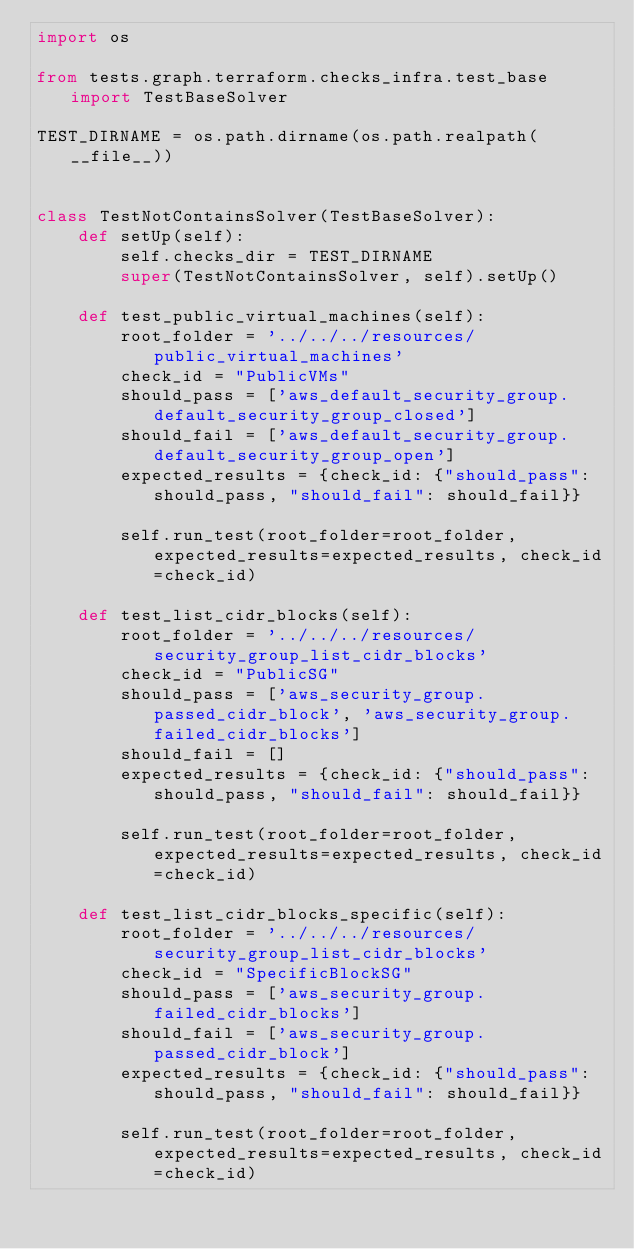<code> <loc_0><loc_0><loc_500><loc_500><_Python_>import os

from tests.graph.terraform.checks_infra.test_base import TestBaseSolver

TEST_DIRNAME = os.path.dirname(os.path.realpath(__file__))


class TestNotContainsSolver(TestBaseSolver):
    def setUp(self):
        self.checks_dir = TEST_DIRNAME
        super(TestNotContainsSolver, self).setUp()

    def test_public_virtual_machines(self):
        root_folder = '../../../resources/public_virtual_machines'
        check_id = "PublicVMs"
        should_pass = ['aws_default_security_group.default_security_group_closed']
        should_fail = ['aws_default_security_group.default_security_group_open']
        expected_results = {check_id: {"should_pass": should_pass, "should_fail": should_fail}}

        self.run_test(root_folder=root_folder, expected_results=expected_results, check_id=check_id)

    def test_list_cidr_blocks(self):
        root_folder = '../../../resources/security_group_list_cidr_blocks'
        check_id = "PublicSG"
        should_pass = ['aws_security_group.passed_cidr_block', 'aws_security_group.failed_cidr_blocks']
        should_fail = []
        expected_results = {check_id: {"should_pass": should_pass, "should_fail": should_fail}}

        self.run_test(root_folder=root_folder, expected_results=expected_results, check_id=check_id)

    def test_list_cidr_blocks_specific(self):
        root_folder = '../../../resources/security_group_list_cidr_blocks'
        check_id = "SpecificBlockSG"
        should_pass = ['aws_security_group.failed_cidr_blocks']
        should_fail = ['aws_security_group.passed_cidr_block']
        expected_results = {check_id: {"should_pass": should_pass, "should_fail": should_fail}}

        self.run_test(root_folder=root_folder, expected_results=expected_results, check_id=check_id)
</code> 